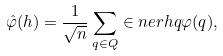Convert formula to latex. <formula><loc_0><loc_0><loc_500><loc_500>\hat { \varphi } ( h ) = \frac { 1 } { \sqrt { n } } \sum _ { q \in Q } \in n e r { h } { q } \varphi ( q ) ,</formula> 